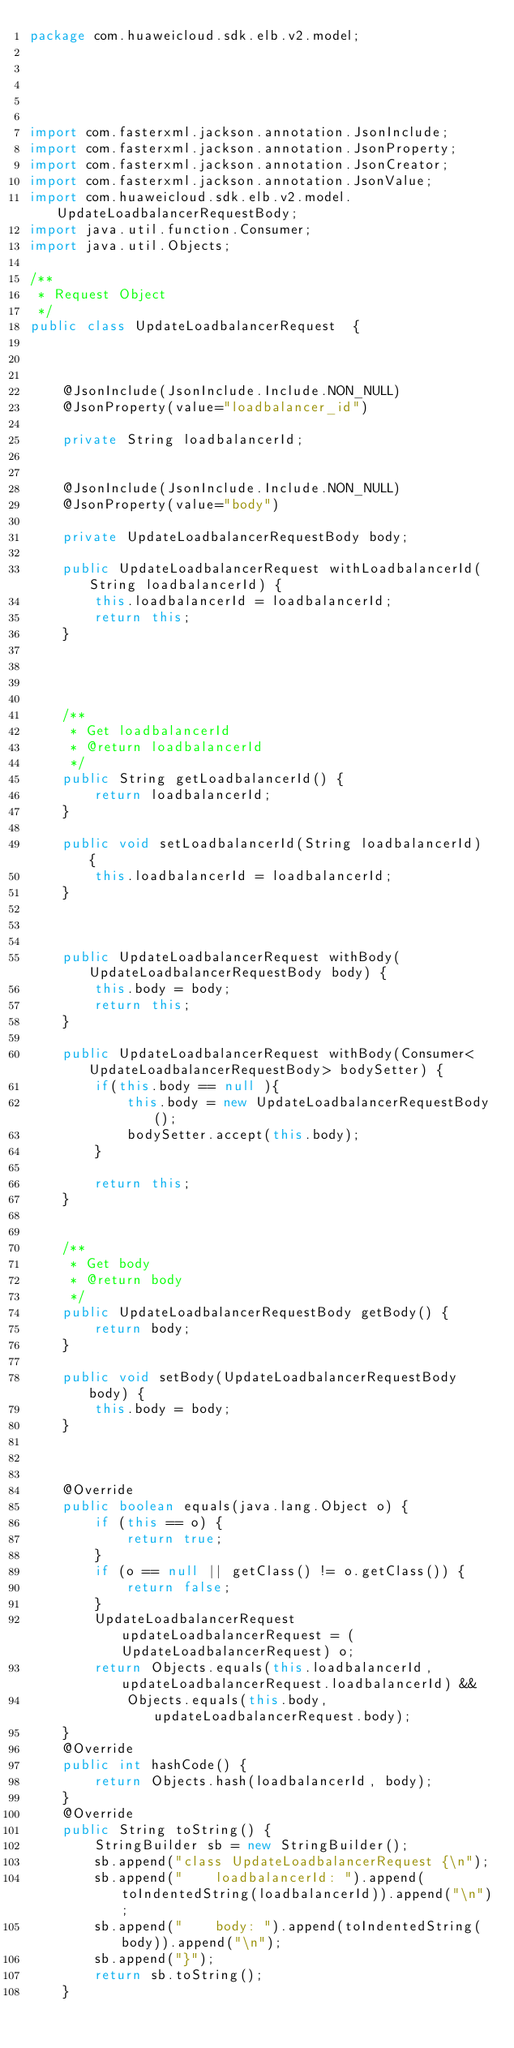<code> <loc_0><loc_0><loc_500><loc_500><_Java_>package com.huaweicloud.sdk.elb.v2.model;





import com.fasterxml.jackson.annotation.JsonInclude;
import com.fasterxml.jackson.annotation.JsonProperty;
import com.fasterxml.jackson.annotation.JsonCreator;
import com.fasterxml.jackson.annotation.JsonValue;
import com.huaweicloud.sdk.elb.v2.model.UpdateLoadbalancerRequestBody;
import java.util.function.Consumer;
import java.util.Objects;

/**
 * Request Object
 */
public class UpdateLoadbalancerRequest  {



    @JsonInclude(JsonInclude.Include.NON_NULL)
    @JsonProperty(value="loadbalancer_id")
    
    private String loadbalancerId;


    @JsonInclude(JsonInclude.Include.NON_NULL)
    @JsonProperty(value="body")
    
    private UpdateLoadbalancerRequestBody body;

    public UpdateLoadbalancerRequest withLoadbalancerId(String loadbalancerId) {
        this.loadbalancerId = loadbalancerId;
        return this;
    }

    


    /**
     * Get loadbalancerId
     * @return loadbalancerId
     */
    public String getLoadbalancerId() {
        return loadbalancerId;
    }

    public void setLoadbalancerId(String loadbalancerId) {
        this.loadbalancerId = loadbalancerId;
    }

    

    public UpdateLoadbalancerRequest withBody(UpdateLoadbalancerRequestBody body) {
        this.body = body;
        return this;
    }

    public UpdateLoadbalancerRequest withBody(Consumer<UpdateLoadbalancerRequestBody> bodySetter) {
        if(this.body == null ){
            this.body = new UpdateLoadbalancerRequestBody();
            bodySetter.accept(this.body);
        }
        
        return this;
    }


    /**
     * Get body
     * @return body
     */
    public UpdateLoadbalancerRequestBody getBody() {
        return body;
    }

    public void setBody(UpdateLoadbalancerRequestBody body) {
        this.body = body;
    }

    

    @Override
    public boolean equals(java.lang.Object o) {
        if (this == o) {
            return true;
        }
        if (o == null || getClass() != o.getClass()) {
            return false;
        }
        UpdateLoadbalancerRequest updateLoadbalancerRequest = (UpdateLoadbalancerRequest) o;
        return Objects.equals(this.loadbalancerId, updateLoadbalancerRequest.loadbalancerId) &&
            Objects.equals(this.body, updateLoadbalancerRequest.body);
    }
    @Override
    public int hashCode() {
        return Objects.hash(loadbalancerId, body);
    }
    @Override
    public String toString() {
        StringBuilder sb = new StringBuilder();
        sb.append("class UpdateLoadbalancerRequest {\n");
        sb.append("    loadbalancerId: ").append(toIndentedString(loadbalancerId)).append("\n");
        sb.append("    body: ").append(toIndentedString(body)).append("\n");
        sb.append("}");
        return sb.toString();
    }</code> 